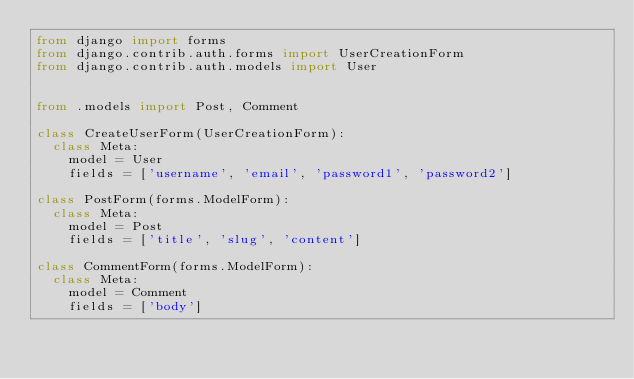Convert code to text. <code><loc_0><loc_0><loc_500><loc_500><_Python_>from django import forms
from django.contrib.auth.forms import UserCreationForm
from django.contrib.auth.models import User


from .models import Post, Comment

class CreateUserForm(UserCreationForm):
  class Meta:
    model = User
    fields = ['username', 'email', 'password1', 'password2']

class PostForm(forms.ModelForm):
  class Meta:
    model = Post
    fields = ['title', 'slug', 'content']

class CommentForm(forms.ModelForm):
  class Meta:
    model = Comment
    fields = ['body']</code> 